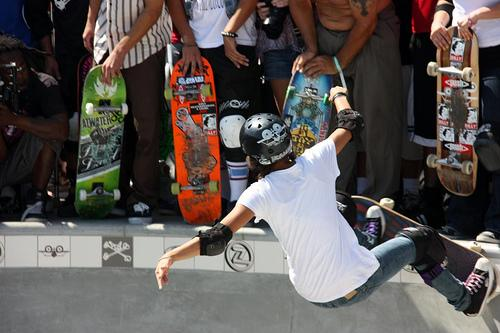Identify a design element present on one of the skateboards in the image. There is a drawing on the skating board. How many skateboards are visible in the image, and what are their distinguishing features? There are five skateboards with different colors like green, orange, blue, tan, and brown, featuring different designs and colored wheels. Identify the protective gear the skater is wearing, and its colors. The skater is wearing a black helmet and black elbow pad. What is the primary activity captured in the image, and who is performing it? A boy is doing tricks in skating. Describe the skater's clothing and appearance in the image. The skater is wearing a white shirt, blue jeans, white knee pad, and black and white shoes with purple/pink laces. Mention a detail about the skater's body art and accessory. The skater has a tattoo and is wearing a wrist band. Describe a part of the image related to the skater's footwear. The skater wears black and white shoes with purple and pink laces. What kind of task can be achieved from this image, involving reasoning and sentiment analysis? Image sentiment analysis task, where the excitement and energy of the skating scene can be analyzed. Provide a brief description of the environment where the skating is taking place. The skating occurs on a grey colored ground with shadows and a visible skating surface. What is the action being performed by another person in the image, and what is their equipment? A man is taking a picture using a black camera. 